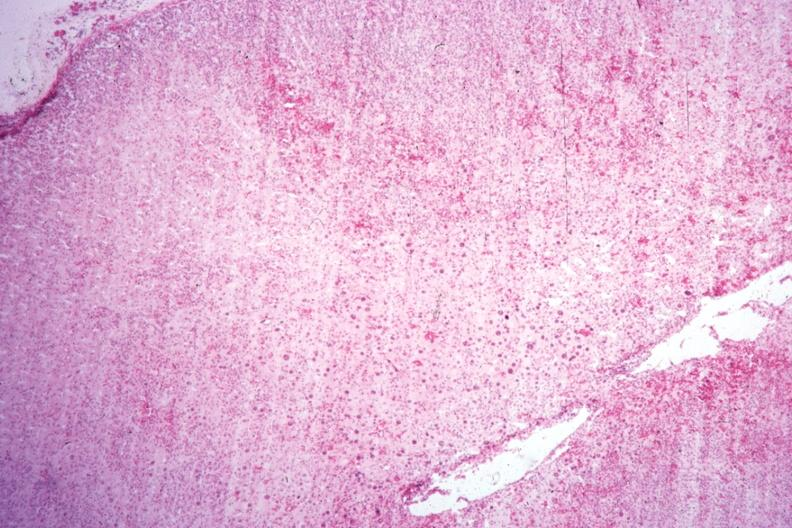what well shown?
Answer the question using a single word or phrase. Localization of cytomegaly 